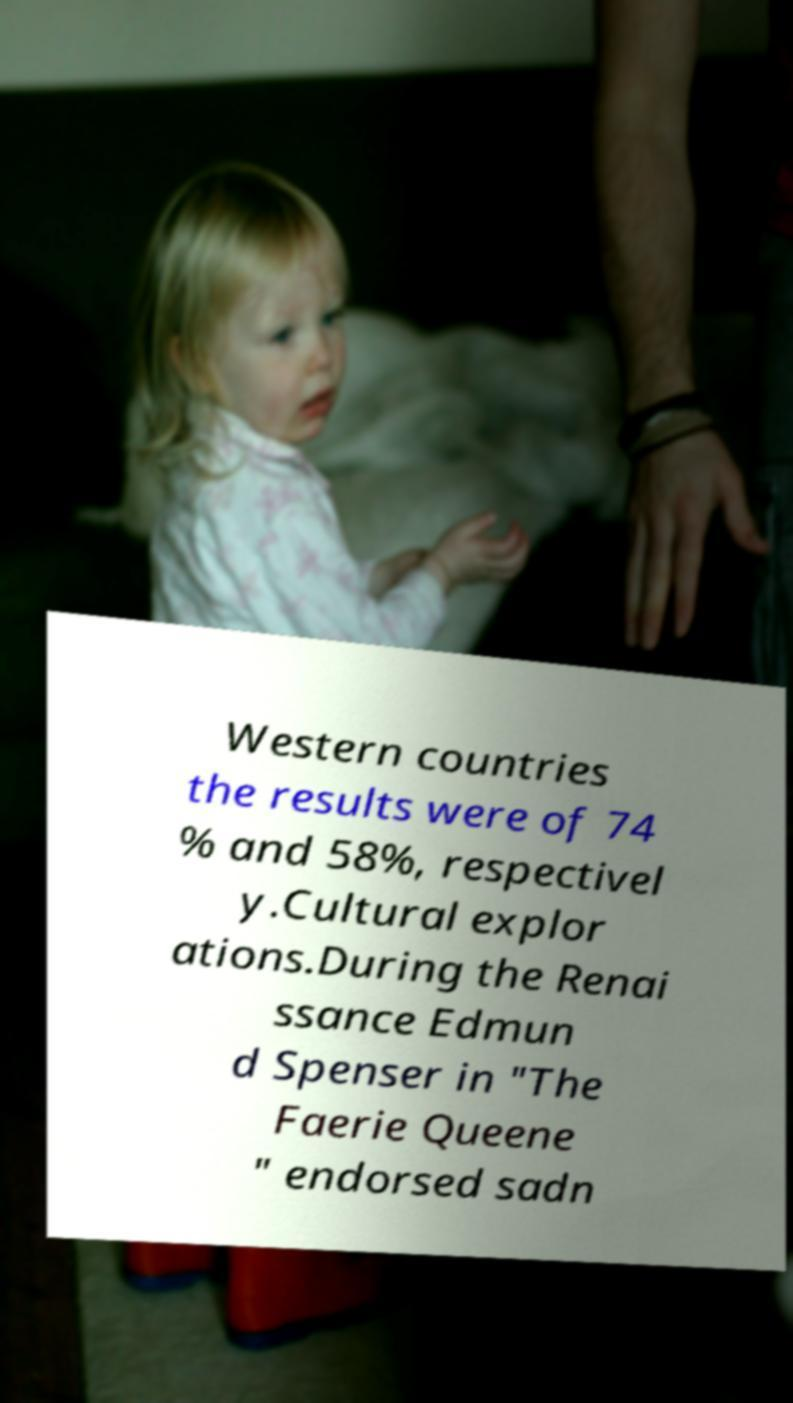I need the written content from this picture converted into text. Can you do that? Western countries the results were of 74 % and 58%, respectivel y.Cultural explor ations.During the Renai ssance Edmun d Spenser in "The Faerie Queene " endorsed sadn 